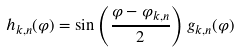<formula> <loc_0><loc_0><loc_500><loc_500>h _ { k , n } ( \varphi ) = \sin \left ( \frac { \varphi - \varphi _ { k , n } } { 2 } \right ) g _ { k , n } ( \varphi )</formula> 